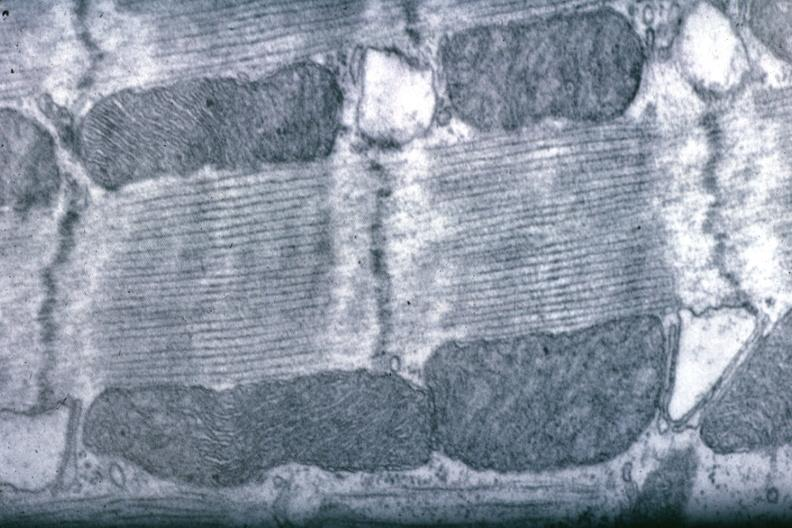s vasculature present?
Answer the question using a single word or phrase. No 